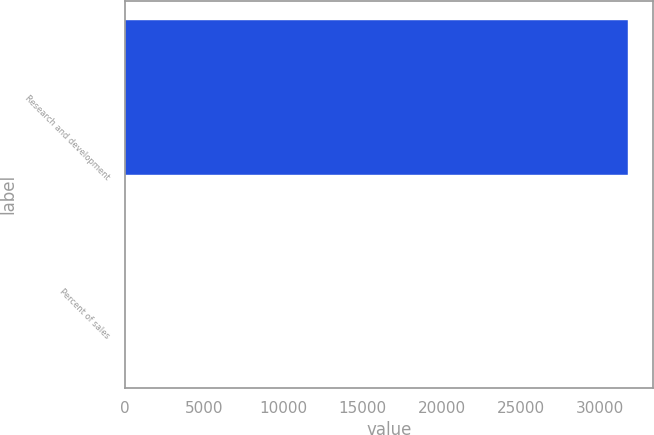<chart> <loc_0><loc_0><loc_500><loc_500><bar_chart><fcel>Research and development<fcel>Percent of sales<nl><fcel>31759<fcel>5.9<nl></chart> 